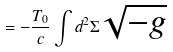<formula> <loc_0><loc_0><loc_500><loc_500>= - \frac { T _ { 0 } } { c } \int d ^ { 2 } \Sigma \sqrt { - g }</formula> 